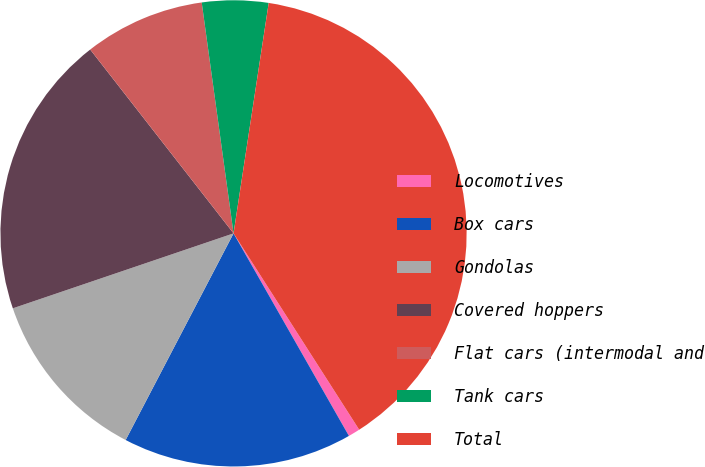Convert chart to OTSL. <chart><loc_0><loc_0><loc_500><loc_500><pie_chart><fcel>Locomotives<fcel>Box cars<fcel>Gondolas<fcel>Covered hoppers<fcel>Flat cars (intermodal and<fcel>Tank cars<fcel>Total<nl><fcel>0.82%<fcel>15.9%<fcel>12.13%<fcel>19.67%<fcel>8.36%<fcel>4.59%<fcel>38.53%<nl></chart> 